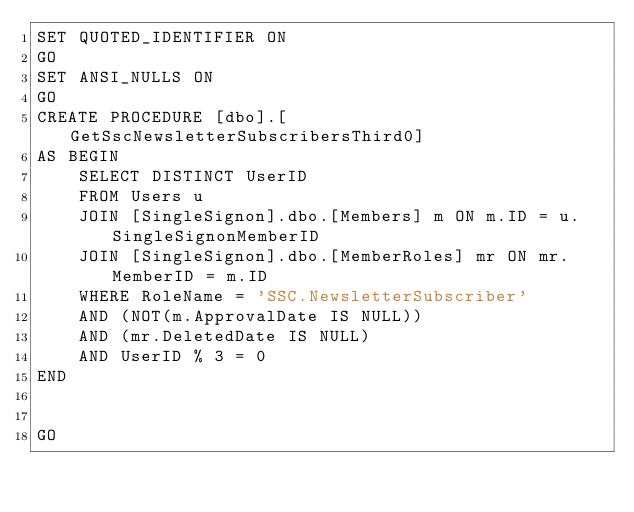<code> <loc_0><loc_0><loc_500><loc_500><_SQL_>SET QUOTED_IDENTIFIER ON
GO
SET ANSI_NULLS ON
GO
CREATE PROCEDURE [dbo].[GetSscNewsletterSubscribersThird0]
AS BEGIN
	SELECT DISTINCT UserID
	FROM Users u
	JOIN [SingleSignon].dbo.[Members] m ON m.ID = u.SingleSignonMemberID
	JOIN [SingleSignon].dbo.[MemberRoles] mr ON mr.MemberID = m.ID
	WHERE RoleName = 'SSC.NewsletterSubscriber'
	AND (NOT(m.ApprovalDate IS NULL))
	AND (mr.DeletedDate IS NULL)
	AND UserID % 3 = 0
END


GO
</code> 